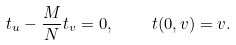Convert formula to latex. <formula><loc_0><loc_0><loc_500><loc_500>t _ { u } - \frac { M } { N } t _ { v } = 0 , \text { } \text { } \text { } \text { } t ( 0 , v ) = v .</formula> 